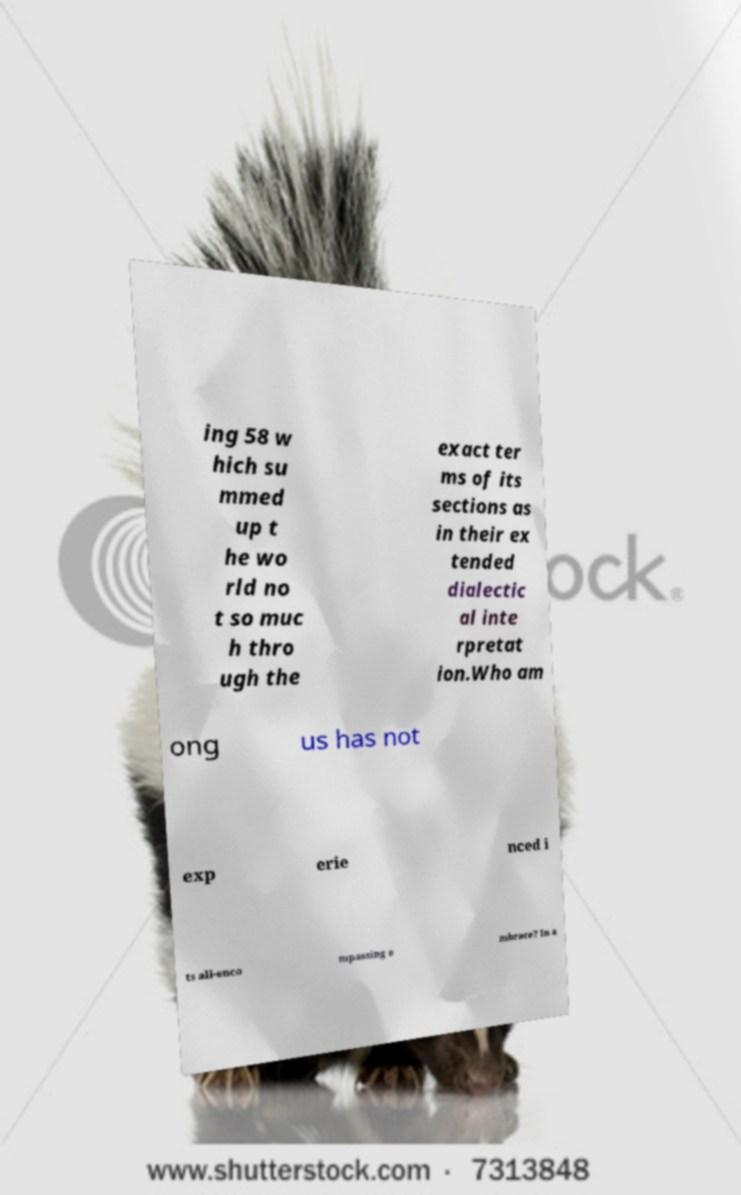Could you extract and type out the text from this image? ing 58 w hich su mmed up t he wo rld no t so muc h thro ugh the exact ter ms of its sections as in their ex tended dialectic al inte rpretat ion.Who am ong us has not exp erie nced i ts all-enco mpassing e mbrace? In a 